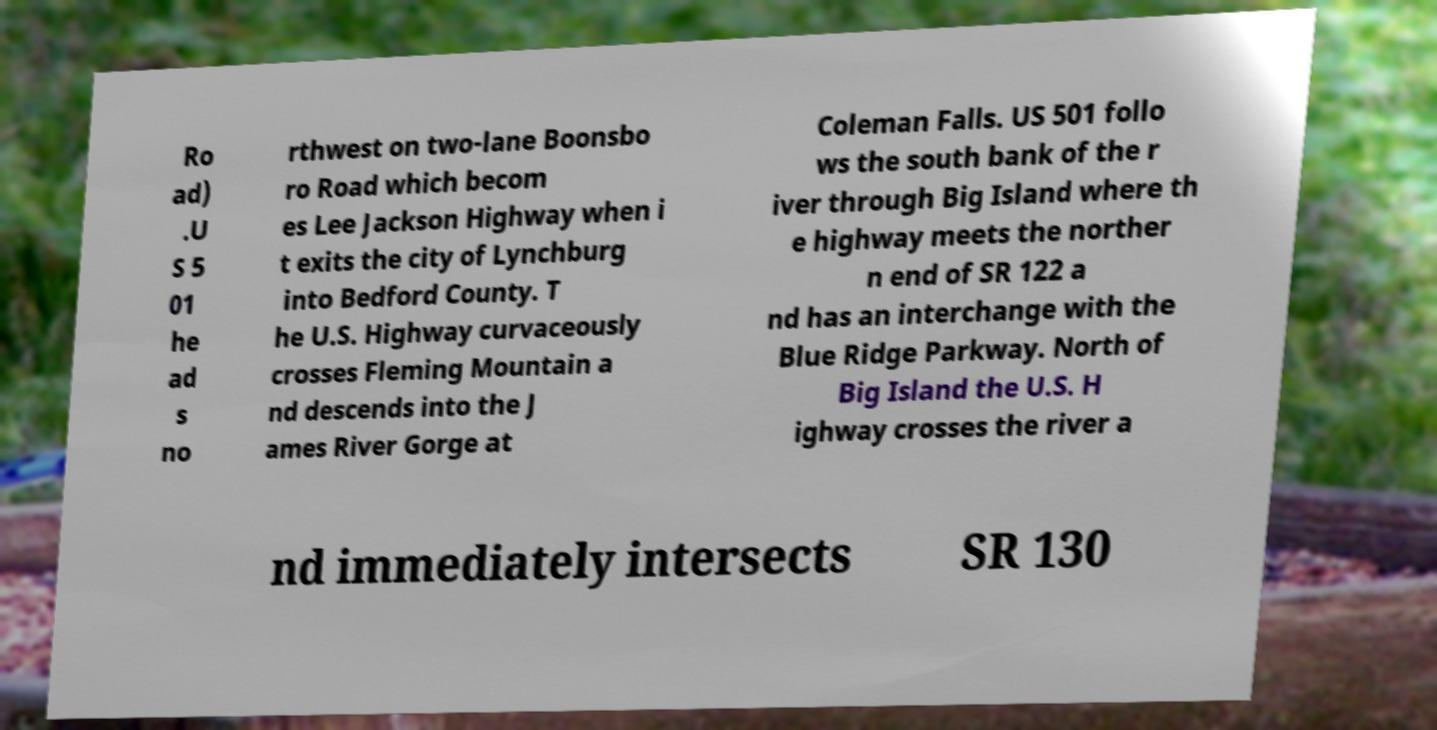Please read and relay the text visible in this image. What does it say? Ro ad) .U S 5 01 he ad s no rthwest on two-lane Boonsbo ro Road which becom es Lee Jackson Highway when i t exits the city of Lynchburg into Bedford County. T he U.S. Highway curvaceously crosses Fleming Mountain a nd descends into the J ames River Gorge at Coleman Falls. US 501 follo ws the south bank of the r iver through Big Island where th e highway meets the norther n end of SR 122 a nd has an interchange with the Blue Ridge Parkway. North of Big Island the U.S. H ighway crosses the river a nd immediately intersects SR 130 